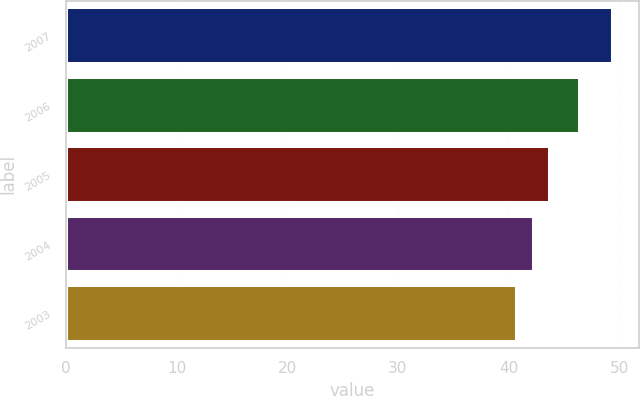Convert chart to OTSL. <chart><loc_0><loc_0><loc_500><loc_500><bar_chart><fcel>2007<fcel>2006<fcel>2005<fcel>2004<fcel>2003<nl><fcel>49.34<fcel>46.33<fcel>43.67<fcel>42.22<fcel>40.68<nl></chart> 